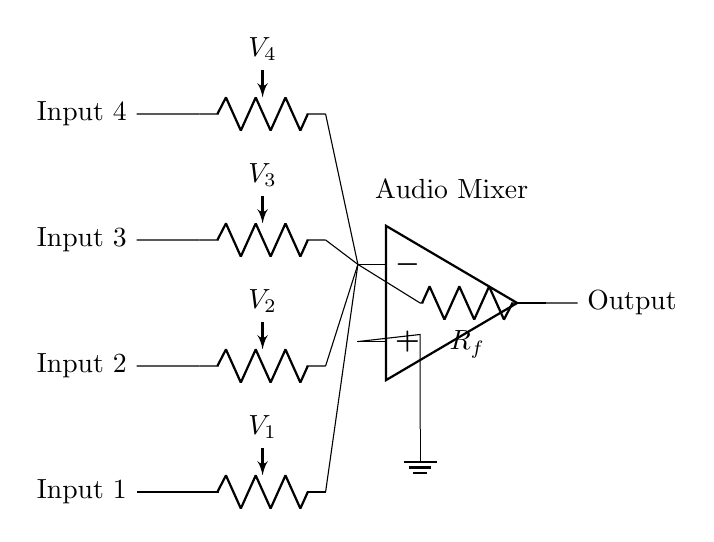What type of circuit is shown? The circuit is an audio mixer circuit, which combines multiple audio signals into one output. The presence of multiple input channels and a summing amplifier indicates its function.
Answer: Audio mixer How many input channels are there? There are four input channels shown in the circuit diagram, as indicated by the four parallel lines at the left side.
Answer: Four What components are used for volume control? The volume control is achieved using potentiometers, denoted as 'pR' in the circuit. Each channel has its own potentiometer for adjusting the audio level.
Answer: Potentiometers What is the purpose of the summing amplifier? The summing amplifier combines the audio signals from all input channels and amplifies the resulting mixed signal for output. This is indicated by the op amp symbol in the diagram.
Answer: Combine signals What does the feedback resistor do? The feedback resistor provides feedback to the summing amplifier, helping to stabilize the gain of the amplified output. This resistor affects how much of the output signal is fed back into the input of the amplifier.
Answer: Stabilizes gain What happens to an input channel when its potentiometer is turned down? When the potentiometer is turned down, it reduces the signal level from that input channel before it reaches the summing amplifier, resulting in a lower overall mix level for that input.
Answer: Decreases signal level 